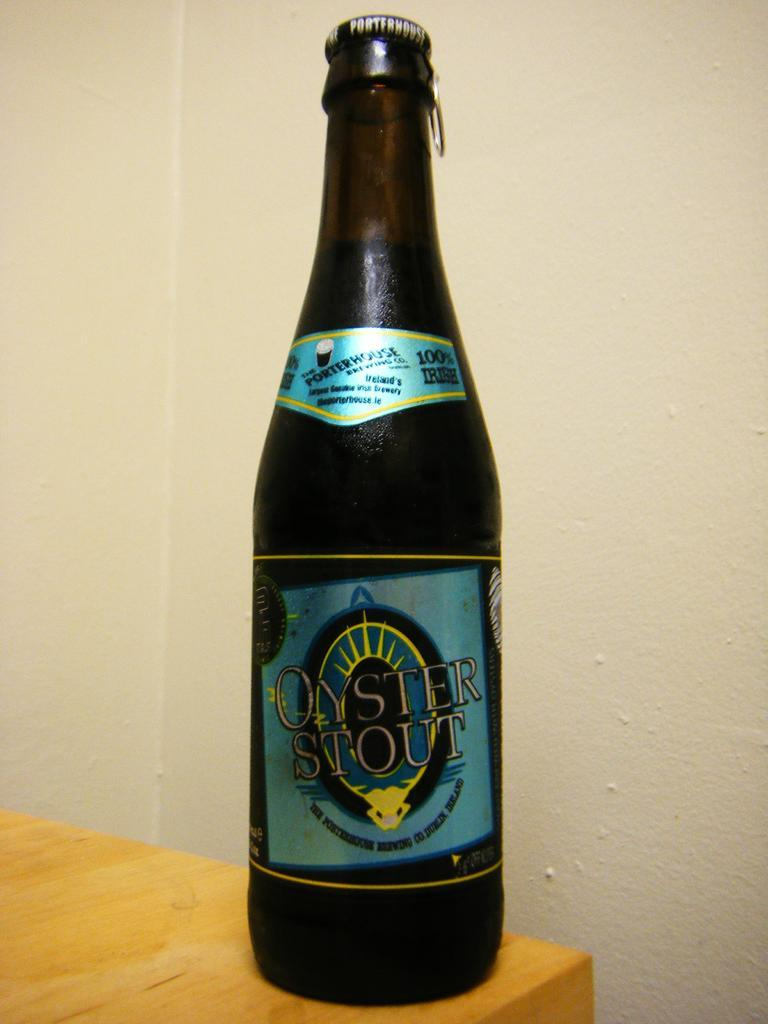<image>
Provide a brief description of the given image. A bottle of Oyster Stout has a label in blue and yellow. 